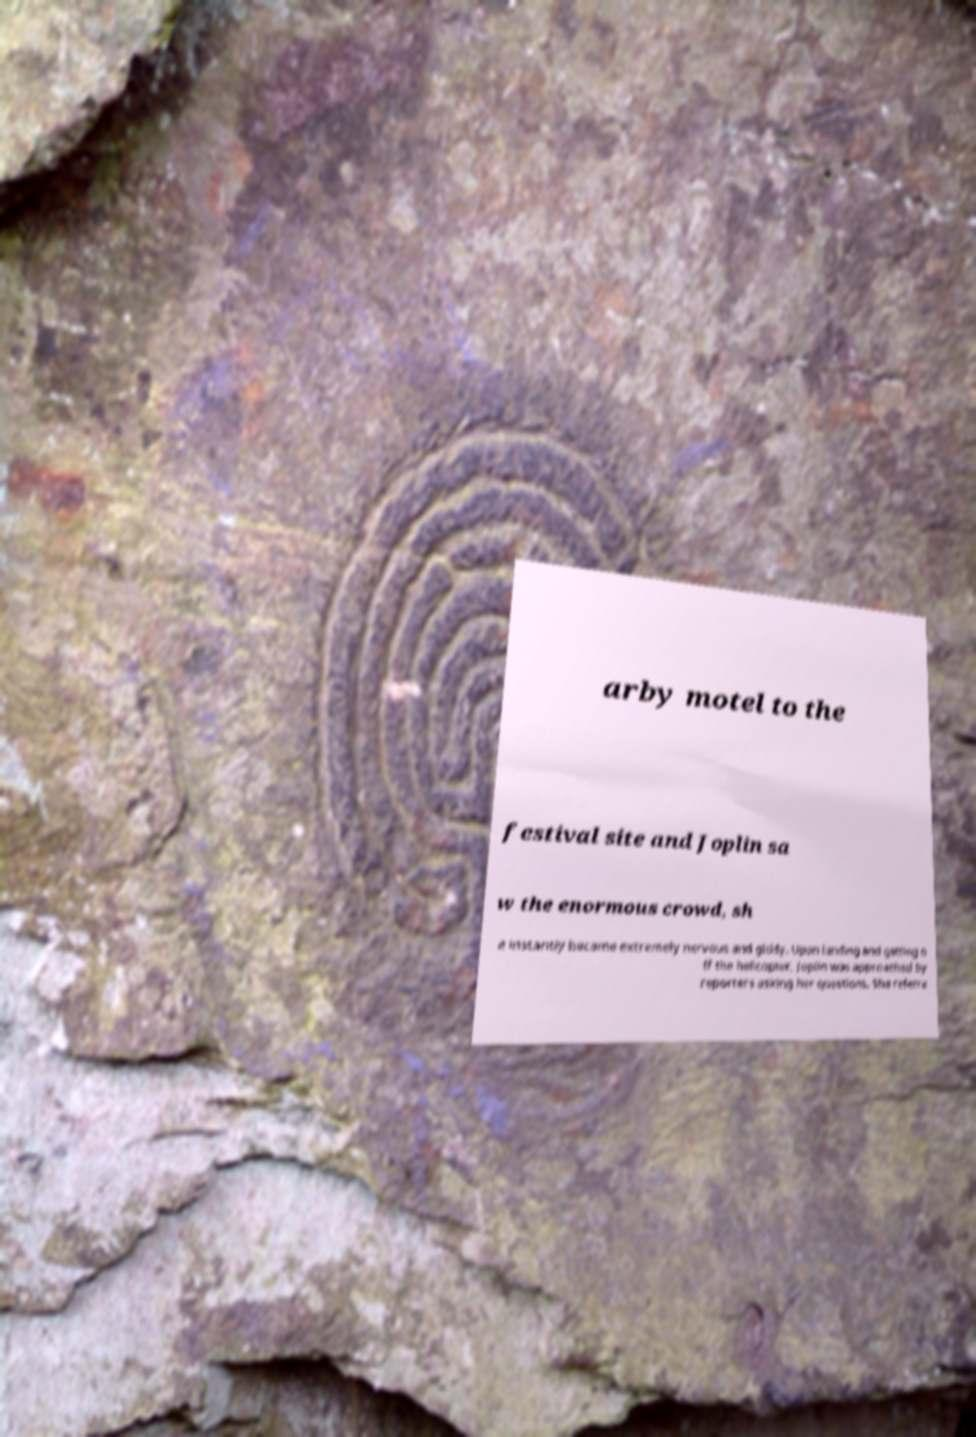Please identify and transcribe the text found in this image. arby motel to the festival site and Joplin sa w the enormous crowd, sh e instantly became extremely nervous and giddy. Upon landing and getting o ff the helicopter, Joplin was approached by reporters asking her questions. She referre 